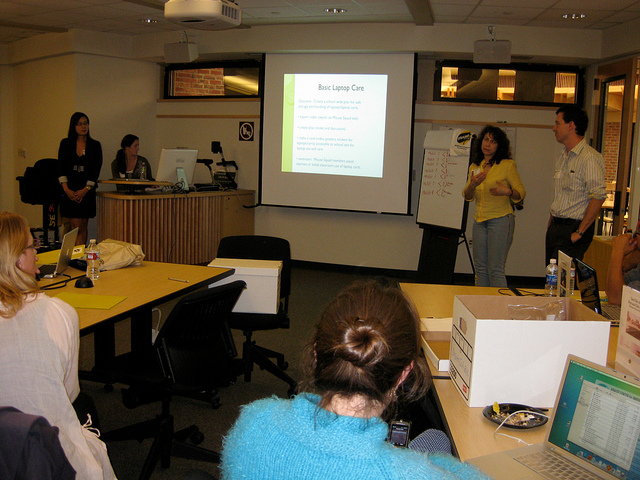Extract all visible text content from this image. Basic Laptop Care 